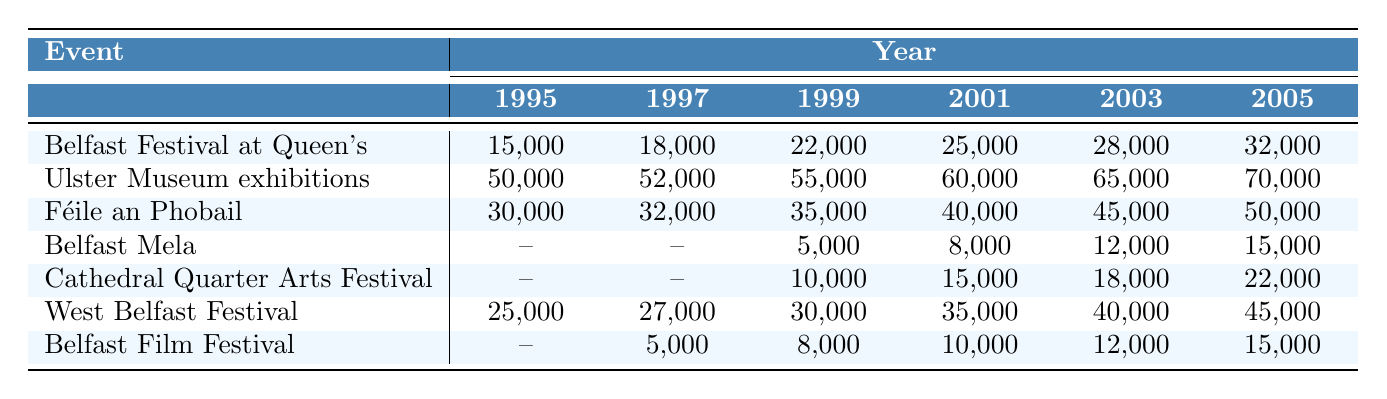What was the attendance at the Belfast Festival at Queen's in 2001? The table shows the attendance for the Belfast Festival at Queen's in 2001 is listed directly under that year, which is 25,000.
Answer: 25,000 Which cultural event had the highest attendance in 2005? By checking the attendance for all events in 2005, the Ulster Museum exhibitions have the highest attendance of 70,000.
Answer: 70,000 What was the average attendance for Féile an Phobail from 1999 to 2005? The attendances from 1999 to 2005 are 35,000, 40,000, 45,000, and 50,000. The total is 170,000. There are 5 data points (including 1999 to 2005), so the average is 170,000/5 = 34,000.
Answer: 34,000 Did attendance at the West Belfast Festival increase every year from 1995 to 2005? Looking at the West Belfast Festival's attendance, it consistently increased from 25,000 in 1995 to 45,000 in 2005, confirming that it did increase every year.
Answer: Yes What is the difference in attendance for the Belfast Film Festival between 1997 and 2005? The attendances are 5,000 in 1997 and 15,000 in 2005. The difference is 15,000 - 5,000 = 10,000.
Answer: 10,000 Which event had the lowest attendance in 1999? Examining the table values for 1999, the lowest attendance is 5,000, which belongs to the Belfast Mela.
Answer: 5,000 How much did attendance for the Cathedral Quarter Arts Festival increase from 1999 to 2005? The attendance in 1999 is 10,000 and in 2005 is 22,000. The increase is calculated as 22,000 - 10,000 = 12,000.
Answer: 12,000 Was there any event that experienced a drop in attendance at any point in the years represented? No, by examining the attendance trends of each event, none showed a decline; all either increased or had missing data points rather than drops.
Answer: No Which event saw the largest percentage increase in attendance from its first recorded year to the last year recorded? For the Belfast Festival at Queen's, the attendance increased from 15,000 in 1995 to 32,000 in 2005. The percentage increase is ((32,000 - 15,000) / 15,000) * 100 = 113.33%. This is the largest percentage increase compared to other events.
Answer: 113.33% 